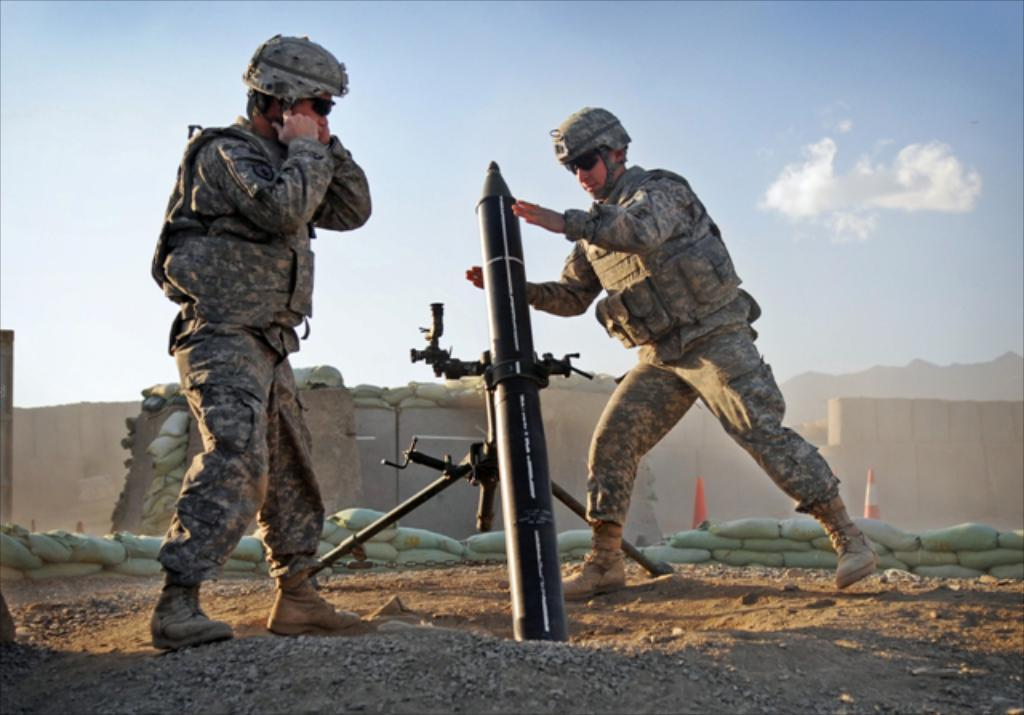How many people are in the image? There are two people standing in the middle of the image. What is the weapon present in the image? The weapon is not specified in the facts provided. What can be seen in the background of the image? There is a wall in the background of the image. What is visible at the top of the image? Clouds and sky are visible at the top of the image. What color is the sweater worn by the person on the left in the image? The facts provided do not mention any sweaters or clothing worn by the people in the image. Can you see a trail leading away from the people in the image? There is no mention of a trail in the facts provided. 